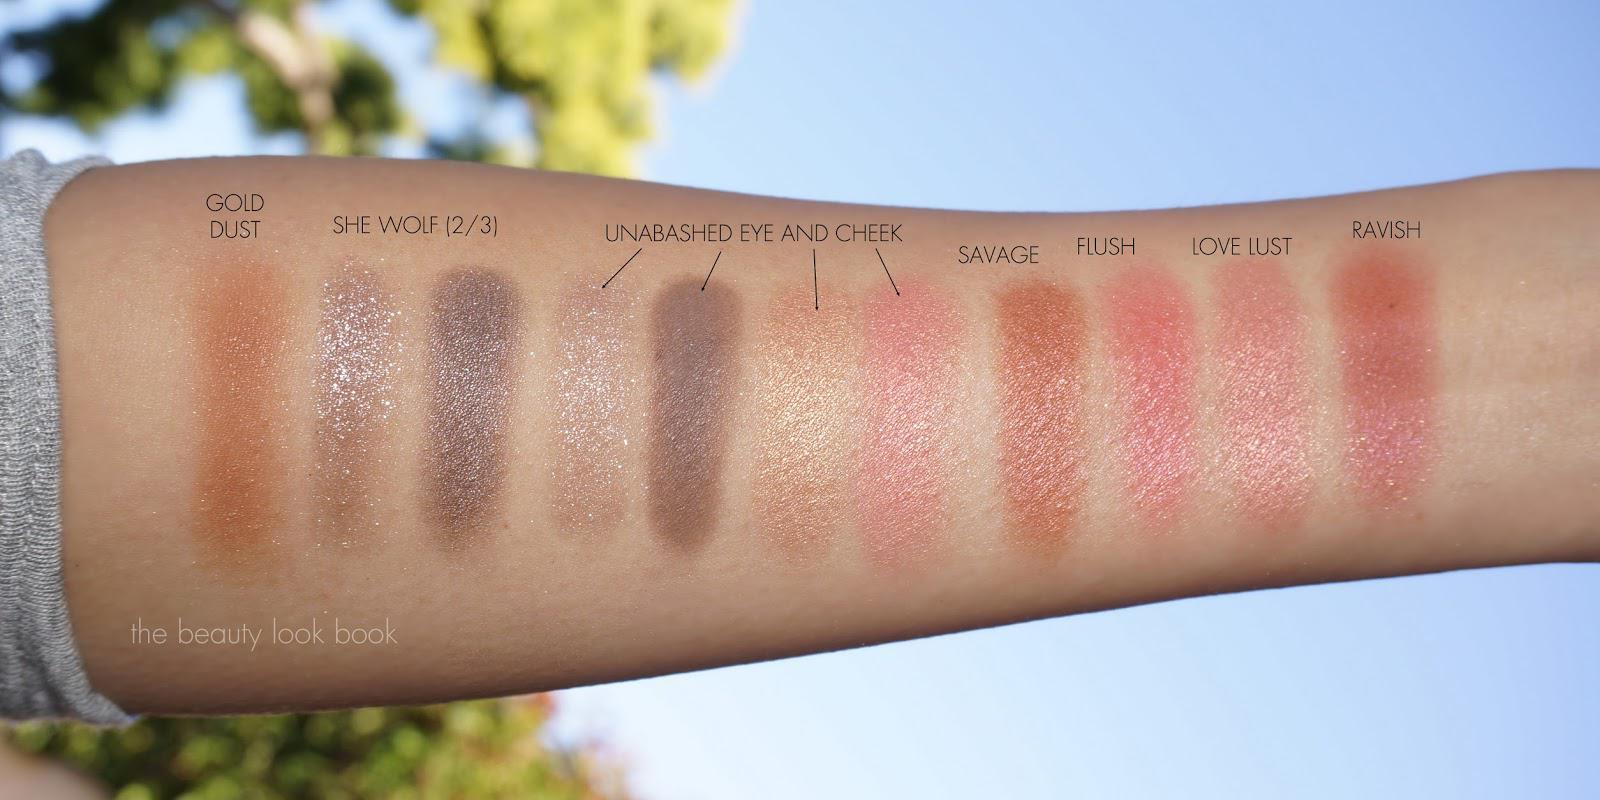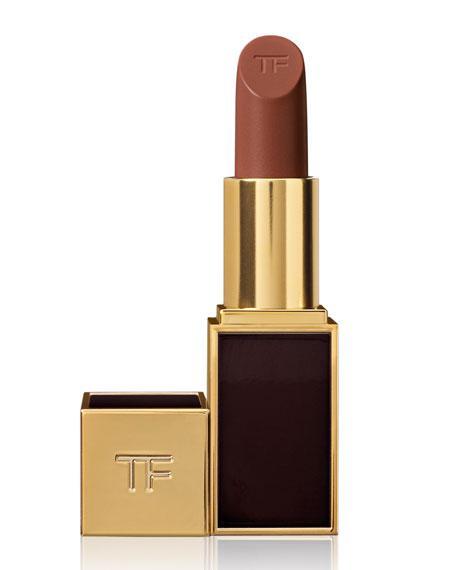The first image is the image on the left, the second image is the image on the right. For the images shown, is this caption "There are multiple lines of lip stick color on an arm." true? Answer yes or no. Yes. The first image is the image on the left, the second image is the image on the right. Evaluate the accuracy of this statement regarding the images: "There are at least 3 tubes of lipstick in these.". Is it true? Answer yes or no. No. 